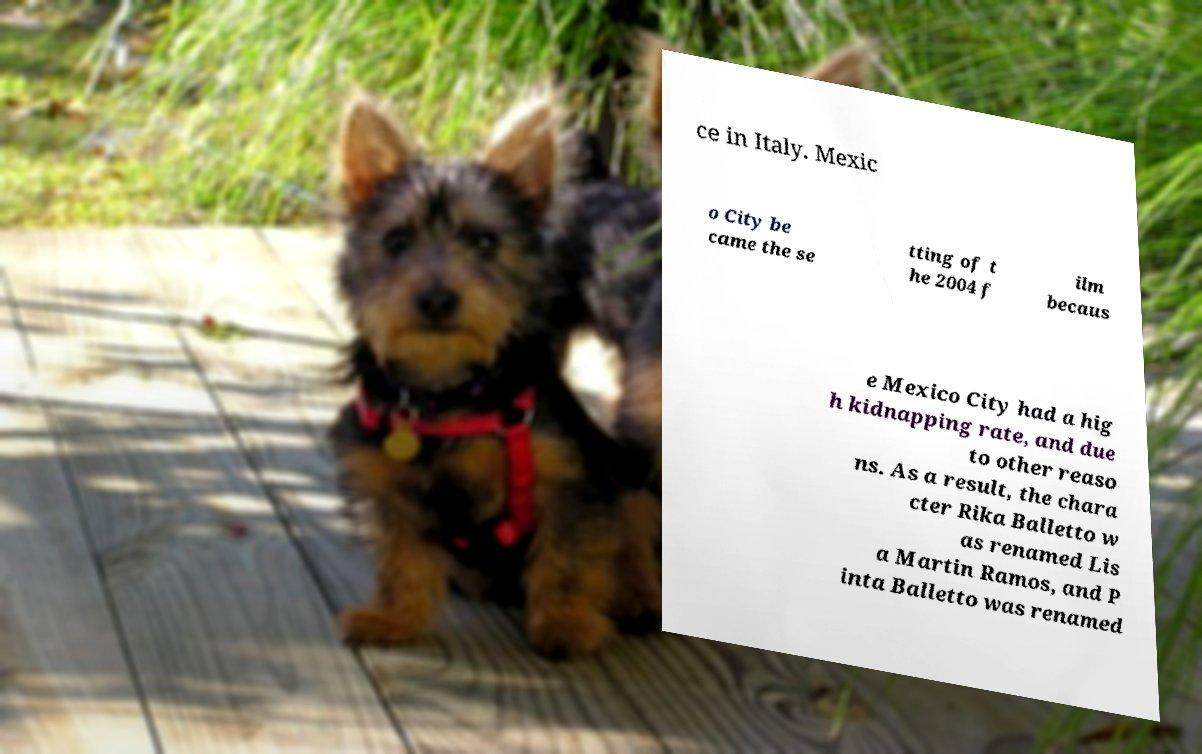Can you read and provide the text displayed in the image?This photo seems to have some interesting text. Can you extract and type it out for me? ce in Italy. Mexic o City be came the se tting of t he 2004 f ilm becaus e Mexico City had a hig h kidnapping rate, and due to other reaso ns. As a result, the chara cter Rika Balletto w as renamed Lis a Martin Ramos, and P inta Balletto was renamed 